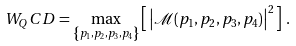<formula> <loc_0><loc_0><loc_500><loc_500>W _ { Q } C D = \max _ { \left \{ p _ { 1 } , p _ { 2 } , p _ { 3 } , p _ { 4 } \right \} } \left [ \, { \left | \mathcal { M } ( p _ { 1 } , p _ { 2 } , p _ { 3 } , p _ { 4 } ) \right | } ^ { 2 } \, \right ] \, .</formula> 